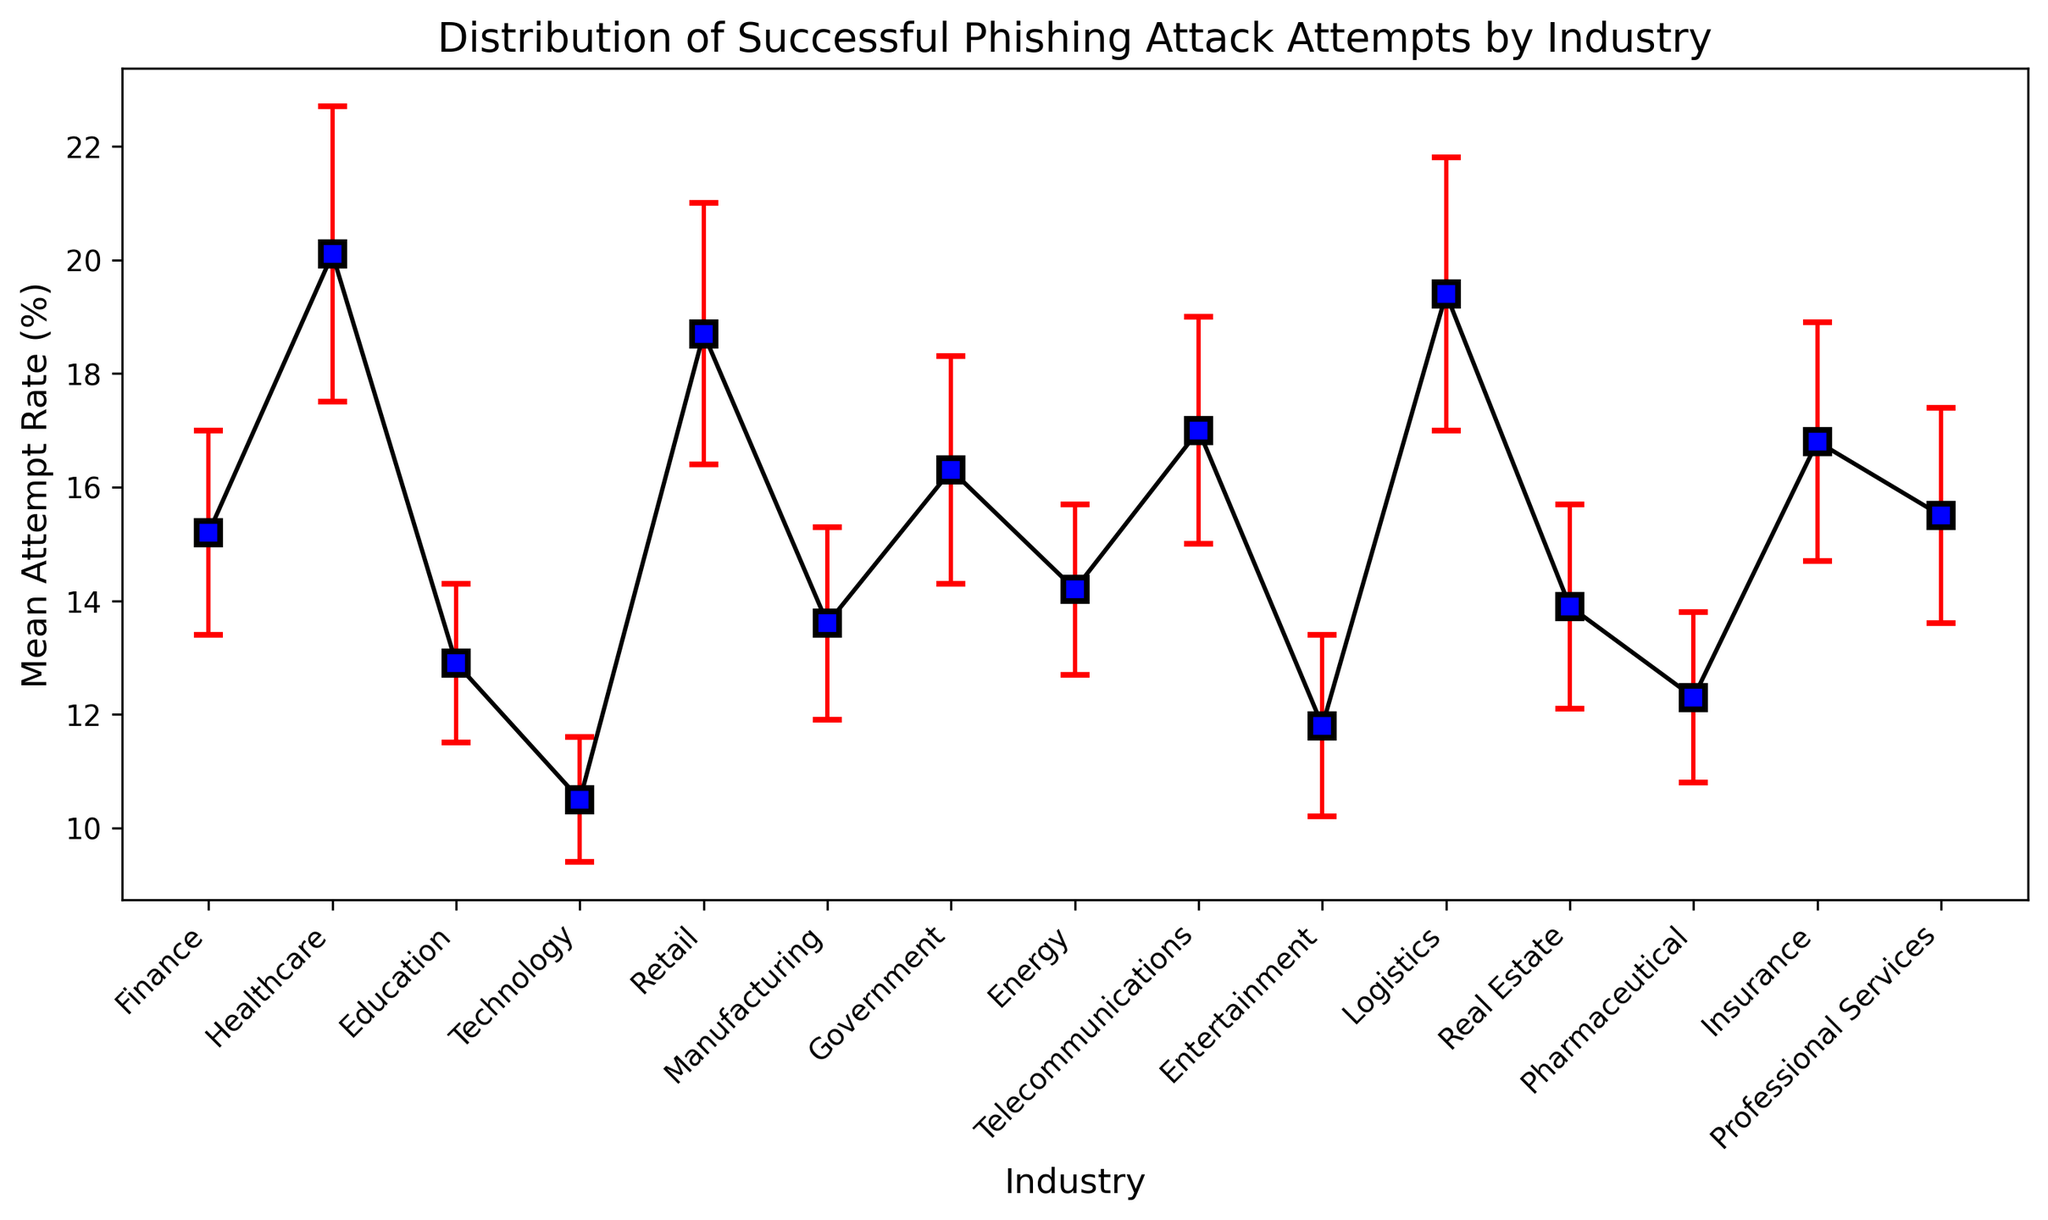What is the industry with the highest mean attempt rate of successful phishing attacks? The figure shows multiple industries with their respective mean attempt rates marked with blue squares and connected by black lines. The industry with the highest mean attempt rate is the one whose blue square is the highest on the y-axis.
Answer: Healthcare Which two industries have the closest mean attempt rates? To answer this, compare the heights of the blue squares for each industry and find the two that are closest. The figure shows that the mean attempt rates for Finance and Professional Services are very close to each other.
Answer: Finance and Professional Services What is the difference in mean attempt rates between the Healthcare and Technology industries? The mean attempt rate for Healthcare is marked higher on the y-axis compared to Technology. Subtract the mean value for Technology (10.5%) from that for Healthcare (20.1%).
Answer: 9.6% Which industry has the largest error bar, indicating the highest standard deviation? The size of the error bar corresponds to the standard deviation. The standard deviation is depicted by the red lines extending above and below the blue squares. The largest error bar is seen for the Healthcare industry.
Answer: Healthcare Is the mean attempt rate of successful phishing attacks for the Retail industry greater than that for Education? To determine this, compare the heights of the blue squares for Retail and Education. The square for Retail is higher than that for Education.
Answer: Yes What is the total mean attempt rate for Government, Energy, and Telecommunications industries combined? Add the mean attempt rates of these three industries: Government (16.3%), Energy (14.2%), and Telecommunications (17.0%).
Answer: 47.5% Which industries have mean attempt rates that are below the overall mean of all industries displayed? First, calculate the overall mean of all displayed industries' mean attempt rates. Then, identify the industries below this value. Overall mean: (15.2 + 20.1 + 12.9 + 10.5 + 18.7 + 13.6 + 16.3 + 14.2 + 17.0 + 11.8 + 19.4 + 13.9 + 12.3 + 16.8 + 15.5) / 15 ≈ 15.1%. Industries below this: Education, Technology, Manufacturing, Entertainment, Real Estate, Pharmaceutical.
Answer: Education, Technology, Manufacturing, Entertainment, Real Estate, Pharmaceutical What is the average standard deviation for all industries represented? Add up all the standard deviations and divide by the number of industries: (1.8 + 2.6 + 1.4 + 1.1 + 2.3 + 1.7 + 2.0 + 1.5 + 2.0 + 1.6 + 2.4 + 1.8 + 1.5 + 2.1 + 1.9) / 15 ≈ 1.86%.
Answer: 1.86% What visual attribute indicates the degree of variability or uncertainty in the mean attempt rates? The red error bars extending above and below the blue squares visually represent the variability or uncertainty (standard deviation) in the mean attempt rates for each industry.
Answer: Error bars 